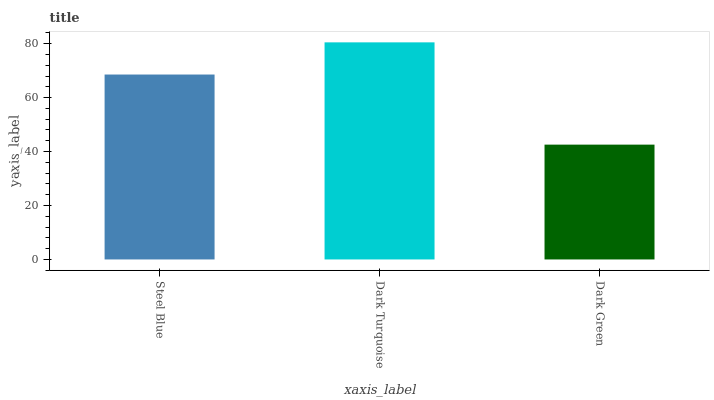Is Dark Green the minimum?
Answer yes or no. Yes. Is Dark Turquoise the maximum?
Answer yes or no. Yes. Is Dark Turquoise the minimum?
Answer yes or no. No. Is Dark Green the maximum?
Answer yes or no. No. Is Dark Turquoise greater than Dark Green?
Answer yes or no. Yes. Is Dark Green less than Dark Turquoise?
Answer yes or no. Yes. Is Dark Green greater than Dark Turquoise?
Answer yes or no. No. Is Dark Turquoise less than Dark Green?
Answer yes or no. No. Is Steel Blue the high median?
Answer yes or no. Yes. Is Steel Blue the low median?
Answer yes or no. Yes. Is Dark Turquoise the high median?
Answer yes or no. No. Is Dark Turquoise the low median?
Answer yes or no. No. 